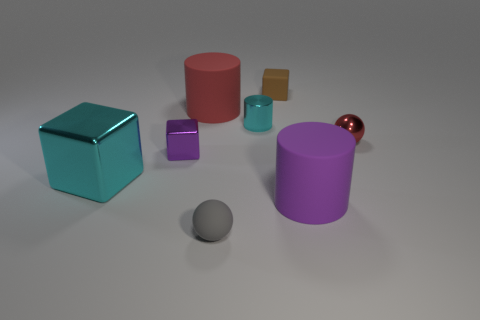There is a red thing that is made of the same material as the small gray object; what shape is it?
Provide a short and direct response. Cylinder. The small sphere in front of the large cylinder that is in front of the red object that is on the right side of the small matte sphere is made of what material?
Provide a short and direct response. Rubber. There is a red metal object; is its size the same as the cyan shiny thing that is in front of the tiny red metal thing?
Give a very brief answer. No. There is a big cyan object that is the same shape as the purple metallic object; what is its material?
Ensure brevity in your answer.  Metal. How big is the matte cylinder right of the small ball that is left of the tiny matte thing that is right of the small gray object?
Provide a succinct answer. Large. Does the red ball have the same size as the red cylinder?
Provide a short and direct response. No. What is the material of the tiny object that is on the right side of the rubber cylinder on the right side of the cyan cylinder?
Keep it short and to the point. Metal. Is the shape of the tiny metallic object to the left of the tiny gray ball the same as the metallic thing that is in front of the tiny purple block?
Your answer should be very brief. Yes. Is the number of gray matte balls right of the tiny metal cylinder the same as the number of tiny cyan cylinders?
Offer a very short reply. No. Is there a small gray ball that is behind the rubber cylinder in front of the big block?
Your response must be concise. No. 